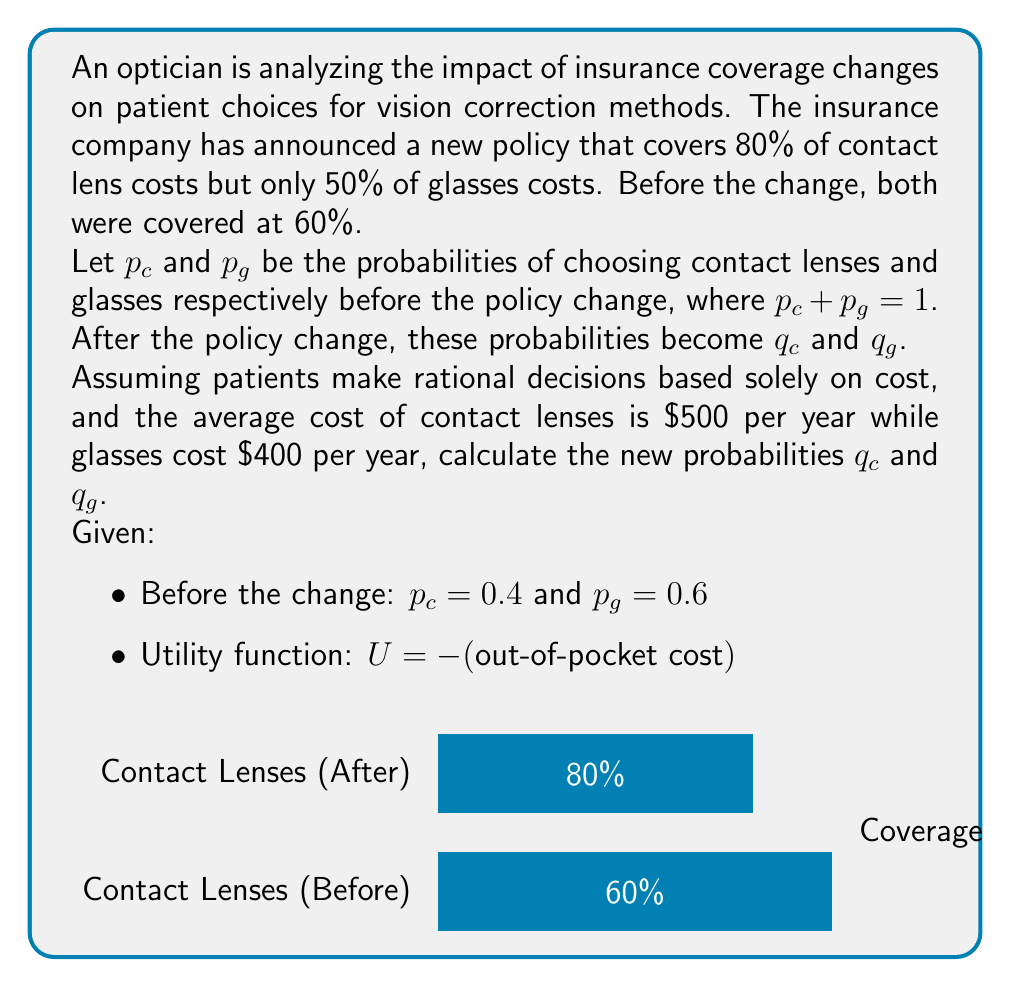Give your solution to this math problem. Let's approach this step-by-step:

1) First, calculate the out-of-pocket costs before and after the policy change:

   Before:
   Contact lenses: $500 * (1 - 0.6) = \$200$
   Glasses: $400 * (1 - 0.6) = \$160$

   After:
   Contact lenses: $500 * (1 - 0.8) = \$100$
   Glasses: $400 * (1 - 0.5) = \$200$

2) The utility for each option is the negative of the out-of-pocket cost:

   Before:
   $U_c = -200$, $U_g = -160$

   After:
   $U_c = -100$, $U_g = -200$

3) To calculate the new probabilities, we can use the logit model from game theory:

   $$q_i = \frac{e^{\beta U_i}}{\sum_j e^{\beta U_j}}$$

   where $\beta$ is a parameter that determines how strongly patients respond to utility differences.

4) We can determine $\beta$ using the initial probabilities:

   $$0.4 = \frac{e^{\beta (-200)}}{e^{\beta (-200)} + e^{\beta (-160)}}$$

   Solving this equation numerically gives $\beta \approx 0.0125$.

5) Now we can calculate the new probabilities:

   $$q_c = \frac{e^{0.0125 (-100)}}{e^{0.0125 (-100)} + e^{0.0125 (-200)}} \approx 0.731$$

   $$q_g = 1 - q_c \approx 0.269$$

Therefore, the new probabilities are approximately $q_c = 0.731$ and $q_g = 0.269$.
Answer: $q_c \approx 0.731$, $q_g \approx 0.269$ 